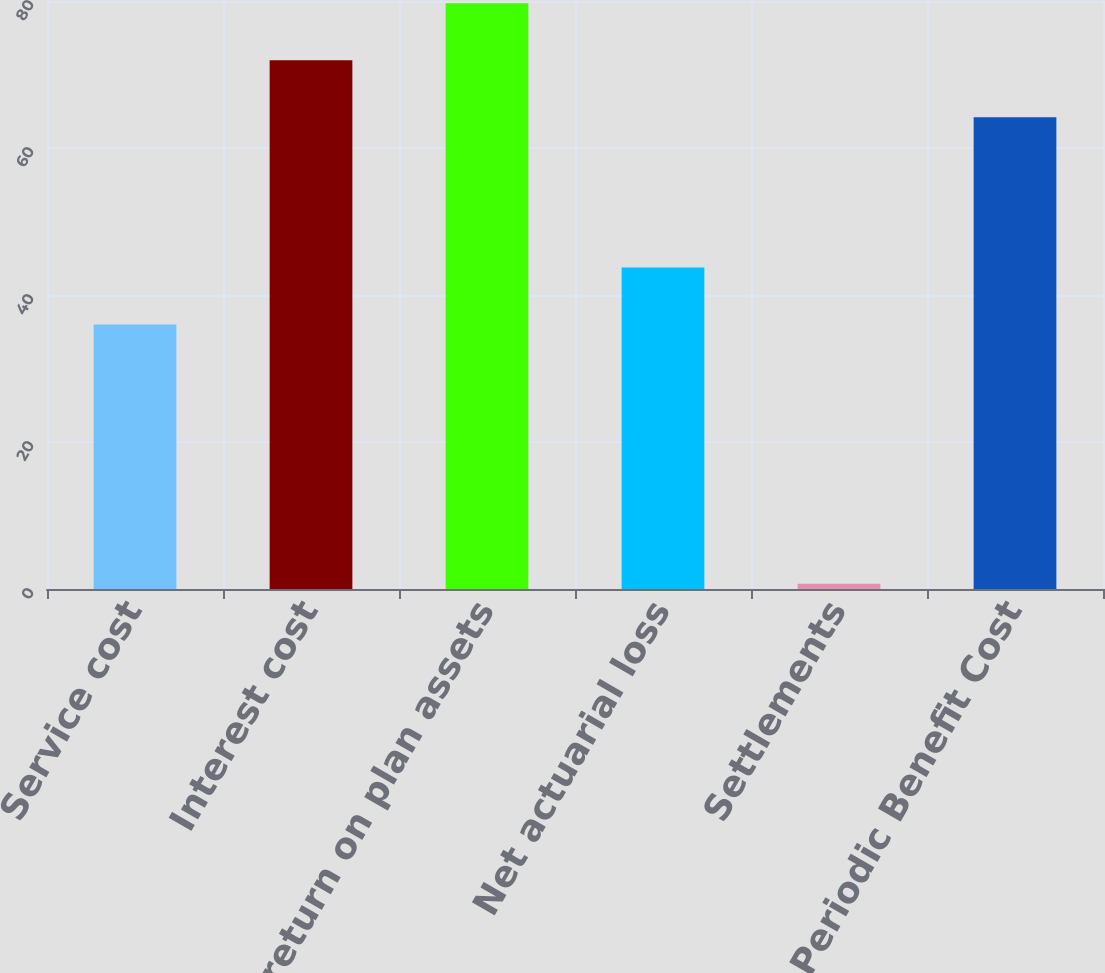Convert chart to OTSL. <chart><loc_0><loc_0><loc_500><loc_500><bar_chart><fcel>Service cost<fcel>Interest cost<fcel>Expected return on plan assets<fcel>Net actuarial loss<fcel>Settlements<fcel>Net Periodic Benefit Cost<nl><fcel>36<fcel>71.94<fcel>79.68<fcel>43.74<fcel>0.7<fcel>64.2<nl></chart> 